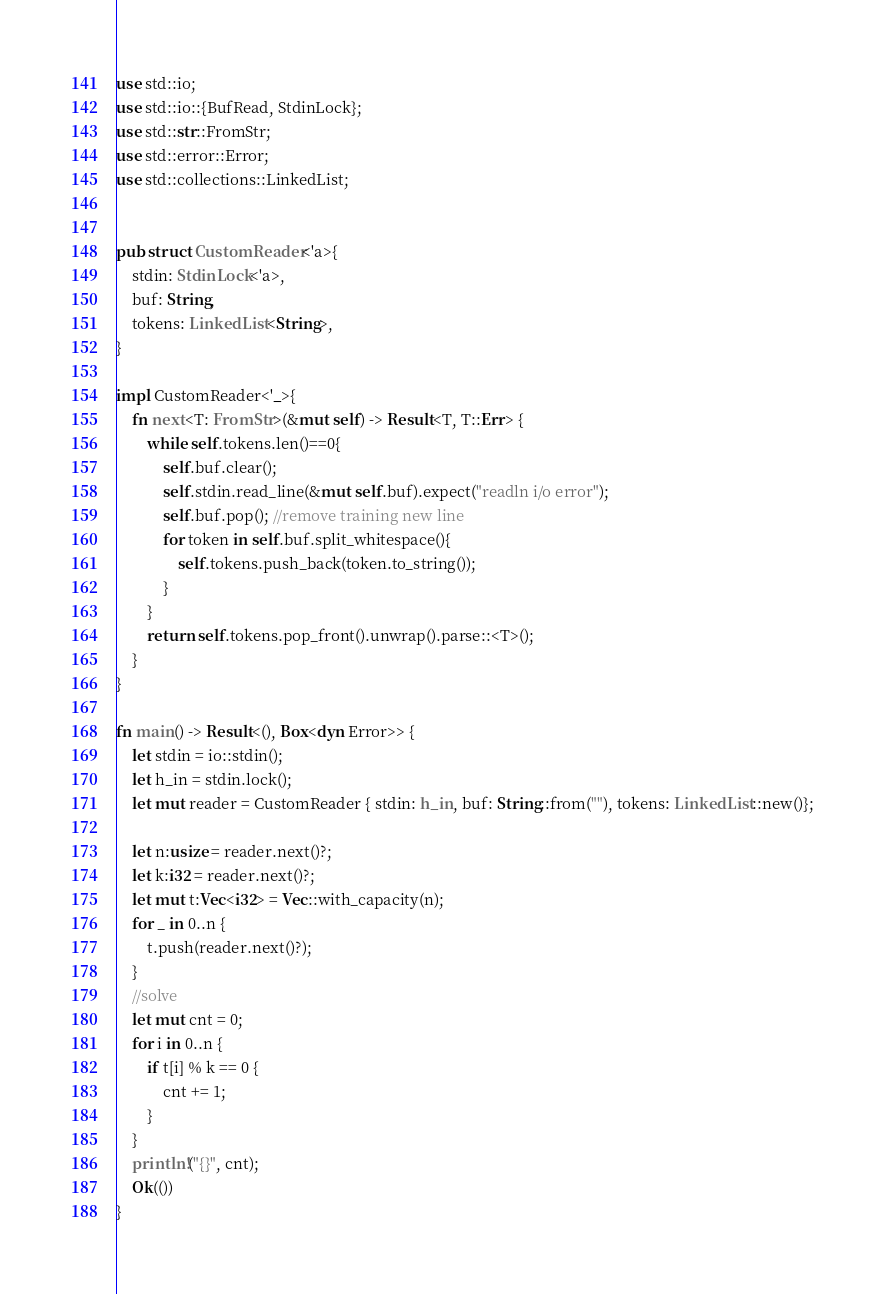Convert code to text. <code><loc_0><loc_0><loc_500><loc_500><_Rust_>use std::io;
use std::io::{BufRead, StdinLock};
use std::str::FromStr;
use std::error::Error;
use std::collections::LinkedList;


pub struct CustomReader<'a>{
    stdin: StdinLock<'a>,
    buf: String,
    tokens: LinkedList<String>,
}

impl CustomReader<'_>{
    fn next<T: FromStr>(&mut self) -> Result<T, T::Err> {
        while self.tokens.len()==0{
            self.buf.clear();
            self.stdin.read_line(&mut self.buf).expect("readln i/o error");
            self.buf.pop(); //remove training new line
            for token in self.buf.split_whitespace(){
                self.tokens.push_back(token.to_string());
            }
        }
        return self.tokens.pop_front().unwrap().parse::<T>();
    }
}

fn main() -> Result<(), Box<dyn Error>> {
    let stdin = io::stdin();
    let h_in = stdin.lock();
    let mut reader = CustomReader { stdin: h_in, buf: String::from(""), tokens: LinkedList::new()};

    let n:usize = reader.next()?;
    let k:i32 = reader.next()?;
    let mut t:Vec<i32> = Vec::with_capacity(n);
    for _ in 0..n {
        t.push(reader.next()?);
    }
    //solve
    let mut cnt = 0;
    for i in 0..n {
        if t[i] % k == 0 {
            cnt += 1;
        }
    }
    println!("{}", cnt);
    Ok(())
}
</code> 